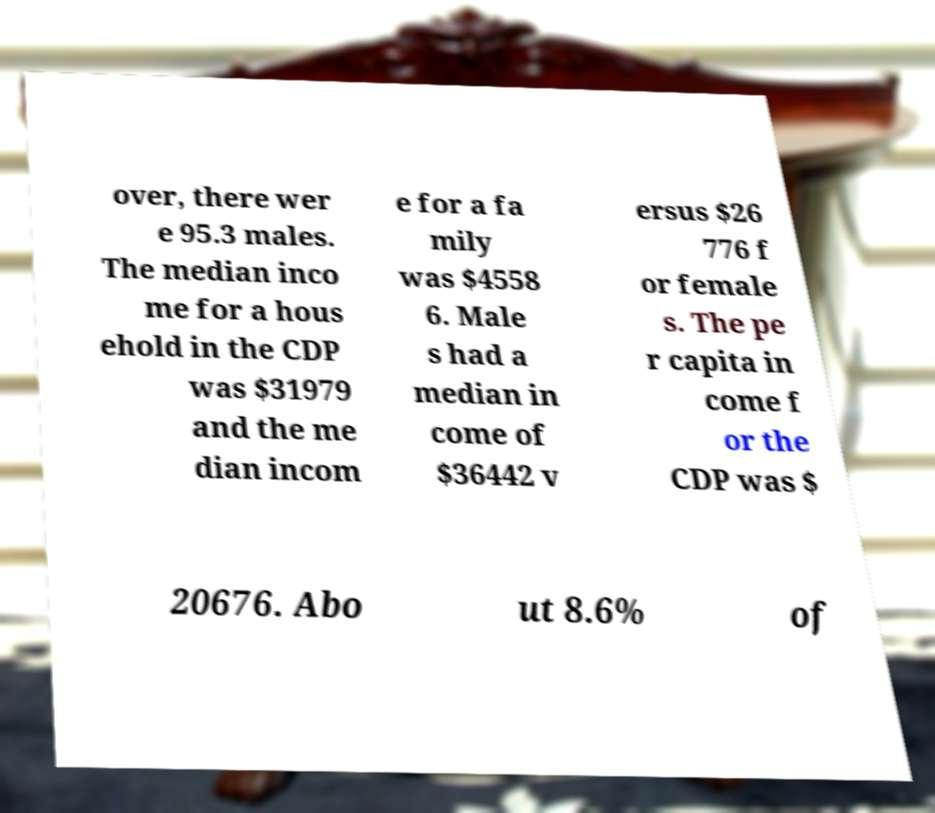Please read and relay the text visible in this image. What does it say? over, there wer e 95.3 males. The median inco me for a hous ehold in the CDP was $31979 and the me dian incom e for a fa mily was $4558 6. Male s had a median in come of $36442 v ersus $26 776 f or female s. The pe r capita in come f or the CDP was $ 20676. Abo ut 8.6% of 